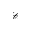<formula> <loc_0><loc_0><loc_500><loc_500>\mathcal { C }</formula> 